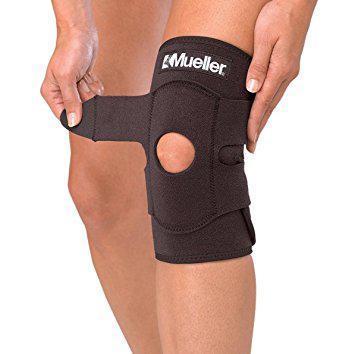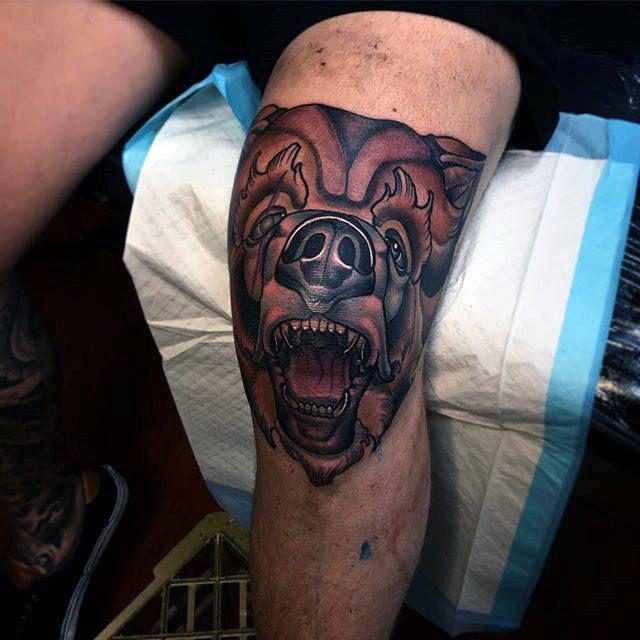The first image is the image on the left, the second image is the image on the right. Considering the images on both sides, is "One black kneepad with a round knee hole is in each image, one of them being adjusted by a person using two hands." valid? Answer yes or no. No. 